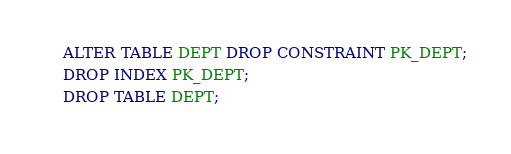<code> <loc_0><loc_0><loc_500><loc_500><_SQL_>ALTER TABLE DEPT DROP CONSTRAINT PK_DEPT;
DROP INDEX PK_DEPT;
DROP TABLE DEPT;</code> 